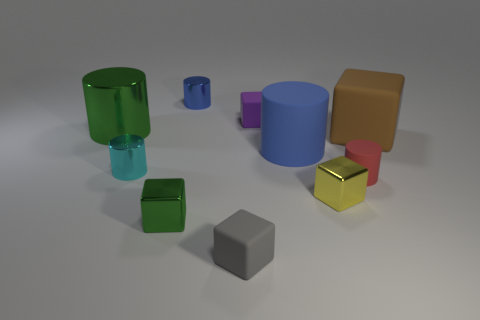Subtract 1 cylinders. How many cylinders are left? 4 Subtract all cyan cylinders. How many cylinders are left? 4 Subtract all green metal blocks. How many blocks are left? 4 Subtract all yellow cylinders. Subtract all red balls. How many cylinders are left? 5 Subtract 1 green cylinders. How many objects are left? 9 Subtract all blue shiny things. Subtract all red rubber objects. How many objects are left? 8 Add 8 red objects. How many red objects are left? 9 Add 9 purple matte objects. How many purple matte objects exist? 10 